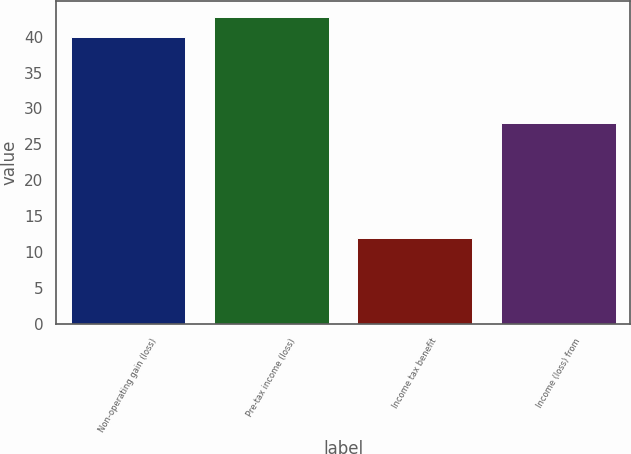Convert chart. <chart><loc_0><loc_0><loc_500><loc_500><bar_chart><fcel>Non-operating gain (loss)<fcel>Pre-tax income (loss)<fcel>Income tax benefit<fcel>Income (loss) from<nl><fcel>40<fcel>42.8<fcel>12<fcel>28<nl></chart> 